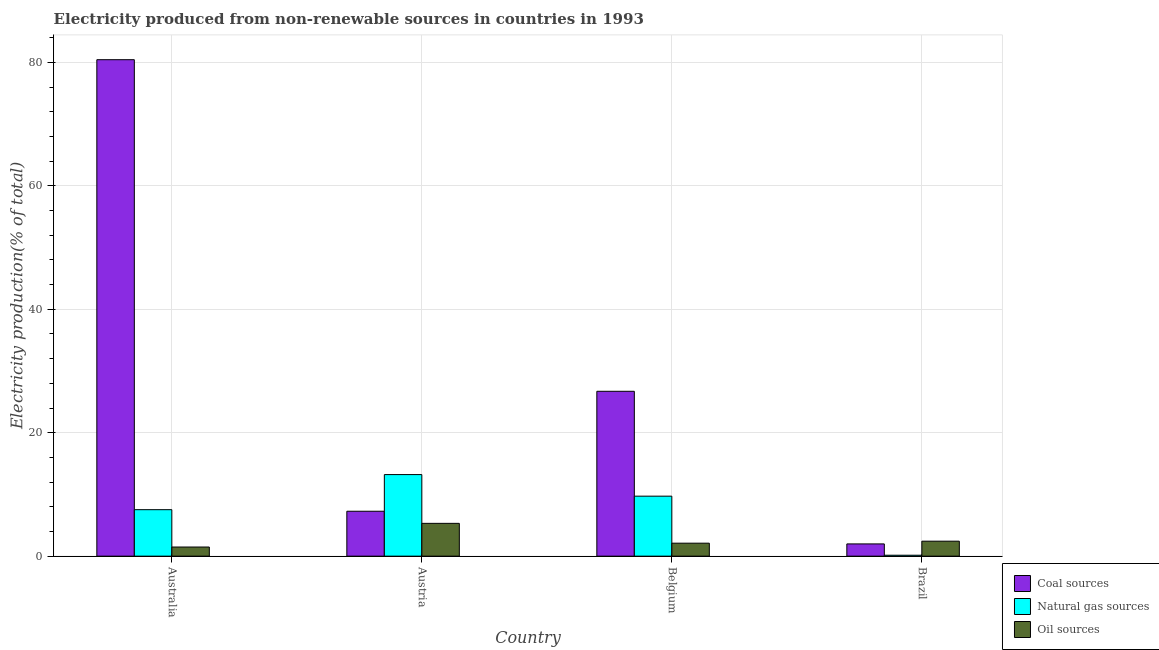How many groups of bars are there?
Your response must be concise. 4. Are the number of bars on each tick of the X-axis equal?
Offer a terse response. Yes. How many bars are there on the 4th tick from the right?
Provide a short and direct response. 3. What is the label of the 4th group of bars from the left?
Offer a terse response. Brazil. In how many cases, is the number of bars for a given country not equal to the number of legend labels?
Provide a short and direct response. 0. What is the percentage of electricity produced by coal in Brazil?
Provide a short and direct response. 1.99. Across all countries, what is the maximum percentage of electricity produced by natural gas?
Provide a succinct answer. 13.22. Across all countries, what is the minimum percentage of electricity produced by coal?
Your answer should be very brief. 1.99. In which country was the percentage of electricity produced by natural gas minimum?
Offer a very short reply. Brazil. What is the total percentage of electricity produced by natural gas in the graph?
Make the answer very short. 30.63. What is the difference between the percentage of electricity produced by oil sources in Austria and that in Belgium?
Offer a terse response. 3.21. What is the difference between the percentage of electricity produced by oil sources in Belgium and the percentage of electricity produced by coal in Austria?
Provide a succinct answer. -5.18. What is the average percentage of electricity produced by natural gas per country?
Provide a succinct answer. 7.66. What is the difference between the percentage of electricity produced by oil sources and percentage of electricity produced by natural gas in Brazil?
Make the answer very short. 2.28. What is the ratio of the percentage of electricity produced by natural gas in Belgium to that in Brazil?
Ensure brevity in your answer.  63.14. What is the difference between the highest and the second highest percentage of electricity produced by oil sources?
Your answer should be very brief. 2.89. What is the difference between the highest and the lowest percentage of electricity produced by natural gas?
Your response must be concise. 13.06. Is the sum of the percentage of electricity produced by natural gas in Belgium and Brazil greater than the maximum percentage of electricity produced by coal across all countries?
Your answer should be compact. No. What does the 2nd bar from the left in Belgium represents?
Offer a very short reply. Natural gas sources. What does the 2nd bar from the right in Belgium represents?
Offer a terse response. Natural gas sources. Is it the case that in every country, the sum of the percentage of electricity produced by coal and percentage of electricity produced by natural gas is greater than the percentage of electricity produced by oil sources?
Ensure brevity in your answer.  No. Are all the bars in the graph horizontal?
Provide a succinct answer. No. How many countries are there in the graph?
Give a very brief answer. 4. What is the difference between two consecutive major ticks on the Y-axis?
Your answer should be very brief. 20. Are the values on the major ticks of Y-axis written in scientific E-notation?
Your response must be concise. No. Does the graph contain grids?
Provide a succinct answer. Yes. Where does the legend appear in the graph?
Offer a terse response. Bottom right. How many legend labels are there?
Make the answer very short. 3. How are the legend labels stacked?
Keep it short and to the point. Vertical. What is the title of the graph?
Offer a terse response. Electricity produced from non-renewable sources in countries in 1993. Does "ICT services" appear as one of the legend labels in the graph?
Make the answer very short. No. What is the label or title of the X-axis?
Provide a short and direct response. Country. What is the Electricity production(% of total) in Coal sources in Australia?
Your answer should be compact. 80.44. What is the Electricity production(% of total) in Natural gas sources in Australia?
Your answer should be very brief. 7.53. What is the Electricity production(% of total) in Oil sources in Australia?
Make the answer very short. 1.48. What is the Electricity production(% of total) of Coal sources in Austria?
Ensure brevity in your answer.  7.28. What is the Electricity production(% of total) in Natural gas sources in Austria?
Your response must be concise. 13.22. What is the Electricity production(% of total) in Oil sources in Austria?
Provide a succinct answer. 5.32. What is the Electricity production(% of total) in Coal sources in Belgium?
Provide a succinct answer. 26.71. What is the Electricity production(% of total) in Natural gas sources in Belgium?
Provide a short and direct response. 9.72. What is the Electricity production(% of total) of Oil sources in Belgium?
Make the answer very short. 2.11. What is the Electricity production(% of total) in Coal sources in Brazil?
Make the answer very short. 1.99. What is the Electricity production(% of total) in Natural gas sources in Brazil?
Your answer should be compact. 0.15. What is the Electricity production(% of total) in Oil sources in Brazil?
Make the answer very short. 2.43. Across all countries, what is the maximum Electricity production(% of total) in Coal sources?
Your response must be concise. 80.44. Across all countries, what is the maximum Electricity production(% of total) of Natural gas sources?
Provide a short and direct response. 13.22. Across all countries, what is the maximum Electricity production(% of total) in Oil sources?
Ensure brevity in your answer.  5.32. Across all countries, what is the minimum Electricity production(% of total) in Coal sources?
Provide a short and direct response. 1.99. Across all countries, what is the minimum Electricity production(% of total) in Natural gas sources?
Ensure brevity in your answer.  0.15. Across all countries, what is the minimum Electricity production(% of total) in Oil sources?
Offer a terse response. 1.48. What is the total Electricity production(% of total) of Coal sources in the graph?
Offer a terse response. 116.42. What is the total Electricity production(% of total) in Natural gas sources in the graph?
Provide a succinct answer. 30.63. What is the total Electricity production(% of total) in Oil sources in the graph?
Make the answer very short. 11.33. What is the difference between the Electricity production(% of total) in Coal sources in Australia and that in Austria?
Ensure brevity in your answer.  73.16. What is the difference between the Electricity production(% of total) in Natural gas sources in Australia and that in Austria?
Offer a terse response. -5.69. What is the difference between the Electricity production(% of total) of Oil sources in Australia and that in Austria?
Make the answer very short. -3.83. What is the difference between the Electricity production(% of total) of Coal sources in Australia and that in Belgium?
Your answer should be compact. 53.72. What is the difference between the Electricity production(% of total) of Natural gas sources in Australia and that in Belgium?
Provide a succinct answer. -2.19. What is the difference between the Electricity production(% of total) in Oil sources in Australia and that in Belgium?
Give a very brief answer. -0.62. What is the difference between the Electricity production(% of total) of Coal sources in Australia and that in Brazil?
Your answer should be very brief. 78.45. What is the difference between the Electricity production(% of total) in Natural gas sources in Australia and that in Brazil?
Ensure brevity in your answer.  7.38. What is the difference between the Electricity production(% of total) of Oil sources in Australia and that in Brazil?
Ensure brevity in your answer.  -0.95. What is the difference between the Electricity production(% of total) in Coal sources in Austria and that in Belgium?
Offer a terse response. -19.43. What is the difference between the Electricity production(% of total) of Natural gas sources in Austria and that in Belgium?
Make the answer very short. 3.5. What is the difference between the Electricity production(% of total) in Oil sources in Austria and that in Belgium?
Your answer should be very brief. 3.21. What is the difference between the Electricity production(% of total) in Coal sources in Austria and that in Brazil?
Offer a very short reply. 5.29. What is the difference between the Electricity production(% of total) of Natural gas sources in Austria and that in Brazil?
Your response must be concise. 13.06. What is the difference between the Electricity production(% of total) of Oil sources in Austria and that in Brazil?
Your answer should be very brief. 2.89. What is the difference between the Electricity production(% of total) in Coal sources in Belgium and that in Brazil?
Make the answer very short. 24.73. What is the difference between the Electricity production(% of total) of Natural gas sources in Belgium and that in Brazil?
Keep it short and to the point. 9.57. What is the difference between the Electricity production(% of total) of Oil sources in Belgium and that in Brazil?
Give a very brief answer. -0.32. What is the difference between the Electricity production(% of total) of Coal sources in Australia and the Electricity production(% of total) of Natural gas sources in Austria?
Keep it short and to the point. 67.22. What is the difference between the Electricity production(% of total) of Coal sources in Australia and the Electricity production(% of total) of Oil sources in Austria?
Your response must be concise. 75.12. What is the difference between the Electricity production(% of total) of Natural gas sources in Australia and the Electricity production(% of total) of Oil sources in Austria?
Your response must be concise. 2.22. What is the difference between the Electricity production(% of total) in Coal sources in Australia and the Electricity production(% of total) in Natural gas sources in Belgium?
Your response must be concise. 70.71. What is the difference between the Electricity production(% of total) of Coal sources in Australia and the Electricity production(% of total) of Oil sources in Belgium?
Offer a terse response. 78.33. What is the difference between the Electricity production(% of total) in Natural gas sources in Australia and the Electricity production(% of total) in Oil sources in Belgium?
Keep it short and to the point. 5.43. What is the difference between the Electricity production(% of total) of Coal sources in Australia and the Electricity production(% of total) of Natural gas sources in Brazil?
Make the answer very short. 80.28. What is the difference between the Electricity production(% of total) of Coal sources in Australia and the Electricity production(% of total) of Oil sources in Brazil?
Your response must be concise. 78.01. What is the difference between the Electricity production(% of total) of Natural gas sources in Australia and the Electricity production(% of total) of Oil sources in Brazil?
Ensure brevity in your answer.  5.1. What is the difference between the Electricity production(% of total) in Coal sources in Austria and the Electricity production(% of total) in Natural gas sources in Belgium?
Provide a succinct answer. -2.44. What is the difference between the Electricity production(% of total) of Coal sources in Austria and the Electricity production(% of total) of Oil sources in Belgium?
Your answer should be very brief. 5.18. What is the difference between the Electricity production(% of total) of Natural gas sources in Austria and the Electricity production(% of total) of Oil sources in Belgium?
Offer a very short reply. 11.11. What is the difference between the Electricity production(% of total) of Coal sources in Austria and the Electricity production(% of total) of Natural gas sources in Brazil?
Ensure brevity in your answer.  7.13. What is the difference between the Electricity production(% of total) in Coal sources in Austria and the Electricity production(% of total) in Oil sources in Brazil?
Provide a succinct answer. 4.85. What is the difference between the Electricity production(% of total) of Natural gas sources in Austria and the Electricity production(% of total) of Oil sources in Brazil?
Keep it short and to the point. 10.79. What is the difference between the Electricity production(% of total) of Coal sources in Belgium and the Electricity production(% of total) of Natural gas sources in Brazil?
Keep it short and to the point. 26.56. What is the difference between the Electricity production(% of total) of Coal sources in Belgium and the Electricity production(% of total) of Oil sources in Brazil?
Provide a short and direct response. 24.28. What is the difference between the Electricity production(% of total) of Natural gas sources in Belgium and the Electricity production(% of total) of Oil sources in Brazil?
Give a very brief answer. 7.29. What is the average Electricity production(% of total) in Coal sources per country?
Your answer should be compact. 29.1. What is the average Electricity production(% of total) of Natural gas sources per country?
Give a very brief answer. 7.66. What is the average Electricity production(% of total) of Oil sources per country?
Provide a succinct answer. 2.83. What is the difference between the Electricity production(% of total) in Coal sources and Electricity production(% of total) in Natural gas sources in Australia?
Ensure brevity in your answer.  72.9. What is the difference between the Electricity production(% of total) of Coal sources and Electricity production(% of total) of Oil sources in Australia?
Provide a succinct answer. 78.95. What is the difference between the Electricity production(% of total) in Natural gas sources and Electricity production(% of total) in Oil sources in Australia?
Your answer should be very brief. 6.05. What is the difference between the Electricity production(% of total) in Coal sources and Electricity production(% of total) in Natural gas sources in Austria?
Give a very brief answer. -5.94. What is the difference between the Electricity production(% of total) in Coal sources and Electricity production(% of total) in Oil sources in Austria?
Your response must be concise. 1.96. What is the difference between the Electricity production(% of total) in Natural gas sources and Electricity production(% of total) in Oil sources in Austria?
Provide a short and direct response. 7.9. What is the difference between the Electricity production(% of total) of Coal sources and Electricity production(% of total) of Natural gas sources in Belgium?
Make the answer very short. 16.99. What is the difference between the Electricity production(% of total) in Coal sources and Electricity production(% of total) in Oil sources in Belgium?
Give a very brief answer. 24.61. What is the difference between the Electricity production(% of total) of Natural gas sources and Electricity production(% of total) of Oil sources in Belgium?
Provide a short and direct response. 7.62. What is the difference between the Electricity production(% of total) in Coal sources and Electricity production(% of total) in Natural gas sources in Brazil?
Offer a very short reply. 1.83. What is the difference between the Electricity production(% of total) in Coal sources and Electricity production(% of total) in Oil sources in Brazil?
Offer a very short reply. -0.44. What is the difference between the Electricity production(% of total) in Natural gas sources and Electricity production(% of total) in Oil sources in Brazil?
Make the answer very short. -2.28. What is the ratio of the Electricity production(% of total) in Coal sources in Australia to that in Austria?
Ensure brevity in your answer.  11.05. What is the ratio of the Electricity production(% of total) of Natural gas sources in Australia to that in Austria?
Offer a very short reply. 0.57. What is the ratio of the Electricity production(% of total) of Oil sources in Australia to that in Austria?
Your answer should be compact. 0.28. What is the ratio of the Electricity production(% of total) in Coal sources in Australia to that in Belgium?
Give a very brief answer. 3.01. What is the ratio of the Electricity production(% of total) of Natural gas sources in Australia to that in Belgium?
Your response must be concise. 0.77. What is the ratio of the Electricity production(% of total) of Oil sources in Australia to that in Belgium?
Provide a short and direct response. 0.7. What is the ratio of the Electricity production(% of total) in Coal sources in Australia to that in Brazil?
Your answer should be compact. 40.5. What is the ratio of the Electricity production(% of total) of Natural gas sources in Australia to that in Brazil?
Make the answer very short. 48.91. What is the ratio of the Electricity production(% of total) in Oil sources in Australia to that in Brazil?
Keep it short and to the point. 0.61. What is the ratio of the Electricity production(% of total) of Coal sources in Austria to that in Belgium?
Your answer should be very brief. 0.27. What is the ratio of the Electricity production(% of total) of Natural gas sources in Austria to that in Belgium?
Your answer should be compact. 1.36. What is the ratio of the Electricity production(% of total) of Oil sources in Austria to that in Belgium?
Make the answer very short. 2.53. What is the ratio of the Electricity production(% of total) in Coal sources in Austria to that in Brazil?
Ensure brevity in your answer.  3.67. What is the ratio of the Electricity production(% of total) in Natural gas sources in Austria to that in Brazil?
Offer a very short reply. 85.84. What is the ratio of the Electricity production(% of total) in Oil sources in Austria to that in Brazil?
Give a very brief answer. 2.19. What is the ratio of the Electricity production(% of total) in Coal sources in Belgium to that in Brazil?
Provide a short and direct response. 13.45. What is the ratio of the Electricity production(% of total) in Natural gas sources in Belgium to that in Brazil?
Keep it short and to the point. 63.14. What is the ratio of the Electricity production(% of total) in Oil sources in Belgium to that in Brazil?
Your answer should be very brief. 0.87. What is the difference between the highest and the second highest Electricity production(% of total) of Coal sources?
Ensure brevity in your answer.  53.72. What is the difference between the highest and the second highest Electricity production(% of total) of Natural gas sources?
Make the answer very short. 3.5. What is the difference between the highest and the second highest Electricity production(% of total) of Oil sources?
Keep it short and to the point. 2.89. What is the difference between the highest and the lowest Electricity production(% of total) of Coal sources?
Provide a short and direct response. 78.45. What is the difference between the highest and the lowest Electricity production(% of total) of Natural gas sources?
Give a very brief answer. 13.06. What is the difference between the highest and the lowest Electricity production(% of total) in Oil sources?
Provide a short and direct response. 3.83. 